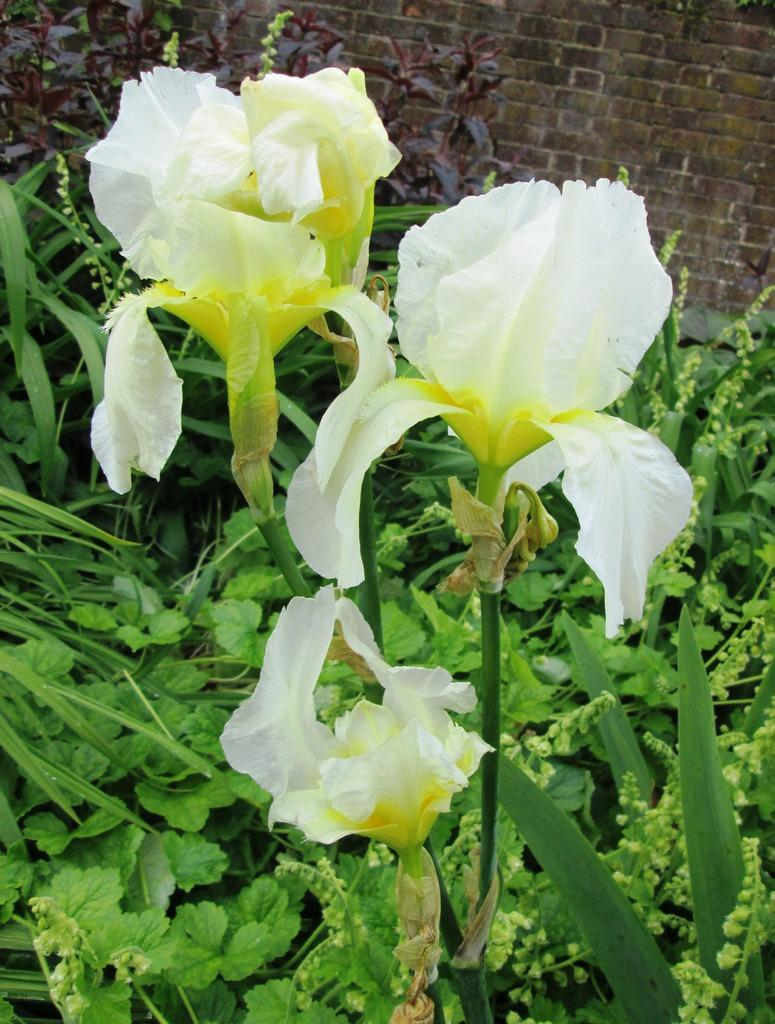What type of living organisms can be seen in the image? There are flowers in the image. What else can be seen in the background of the image? There are various plants and a brick wall in the background of the image. What type of pets can be seen playing in the sand in the image? There are no pets or sand present in the image; it features flowers and plants in the foreground and background. 